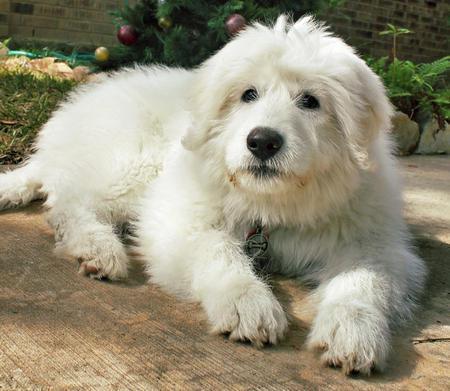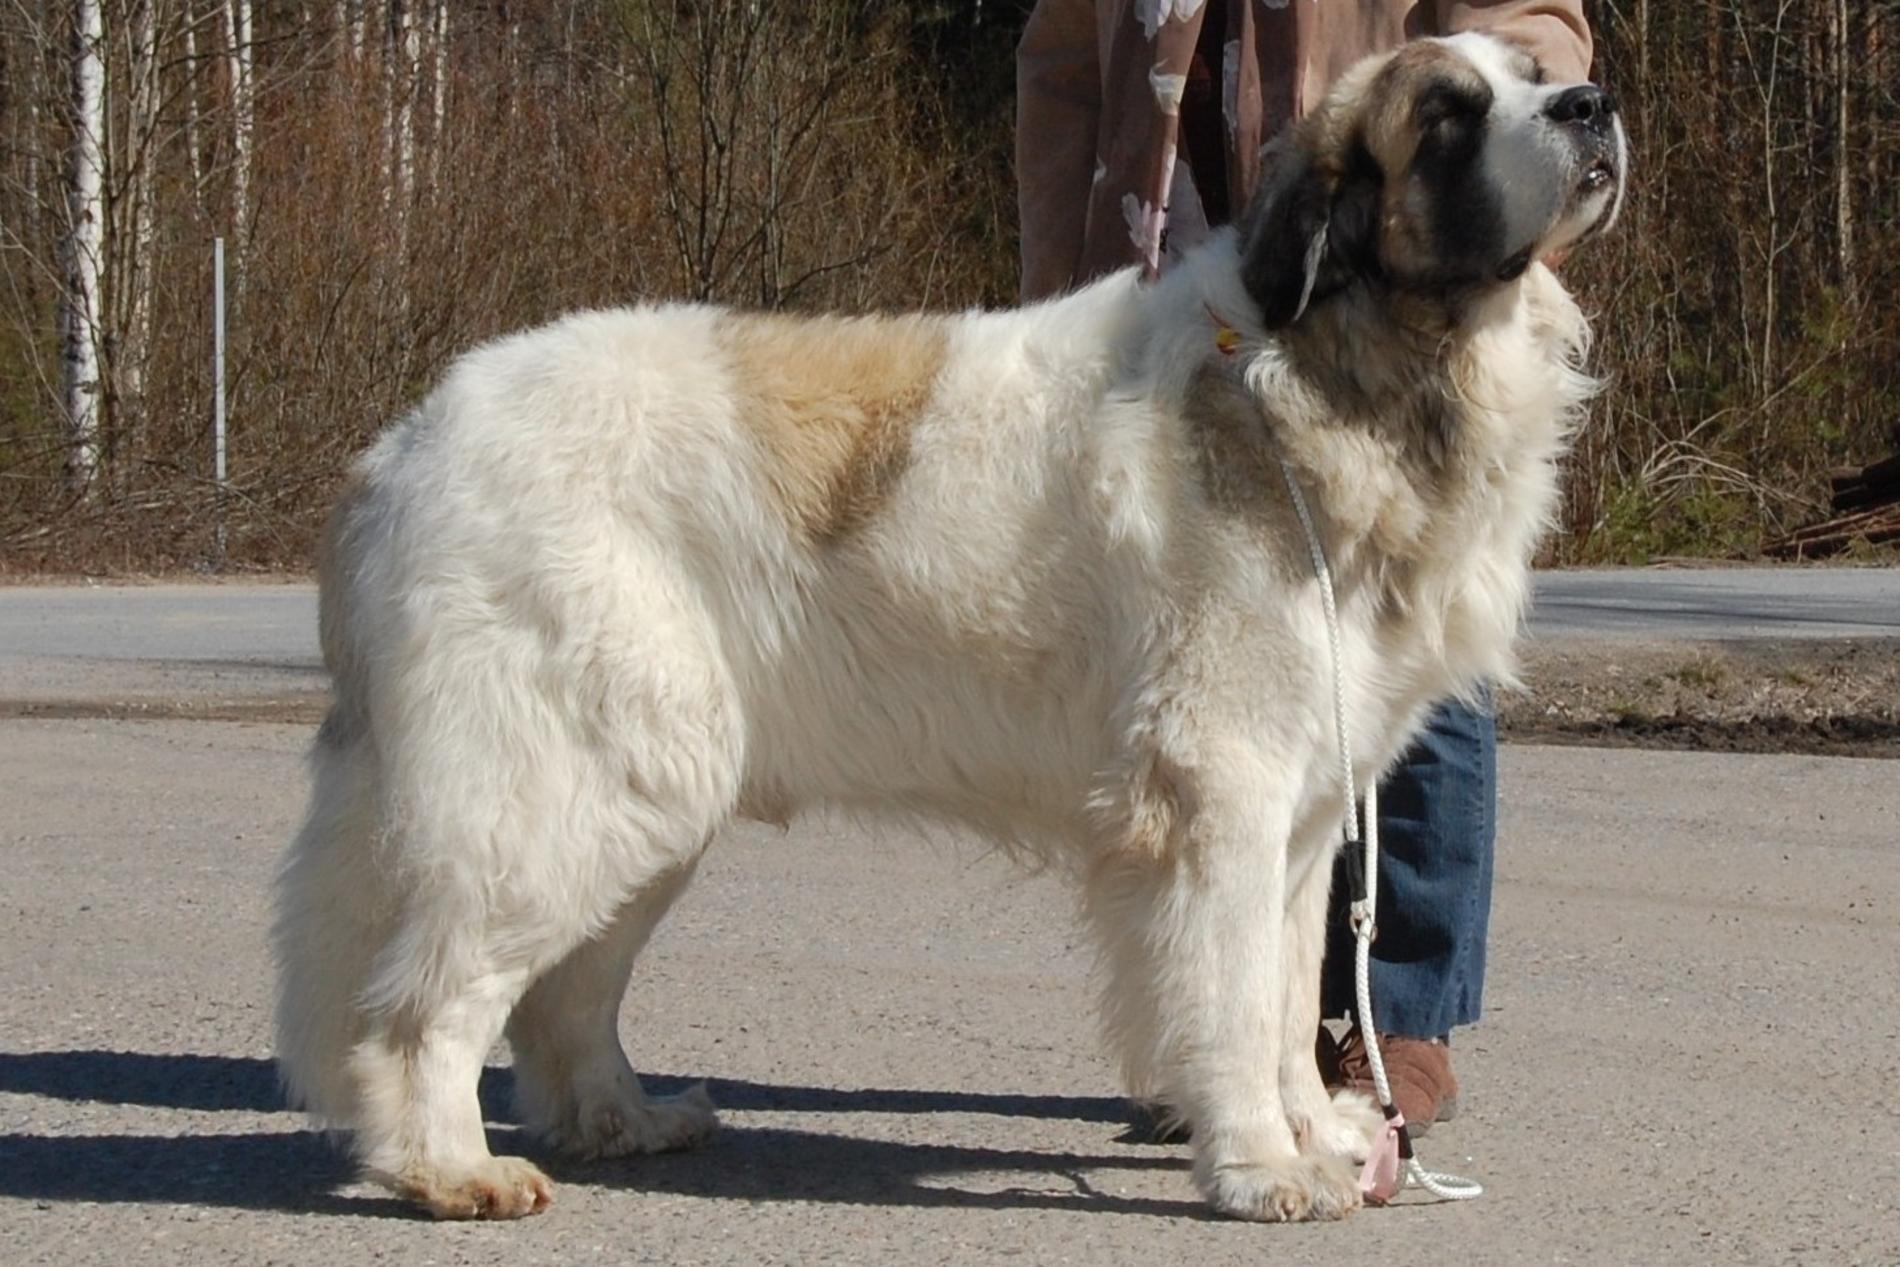The first image is the image on the left, the second image is the image on the right. Considering the images on both sides, is "At least one dog has a brown spot." valid? Answer yes or no. Yes. 